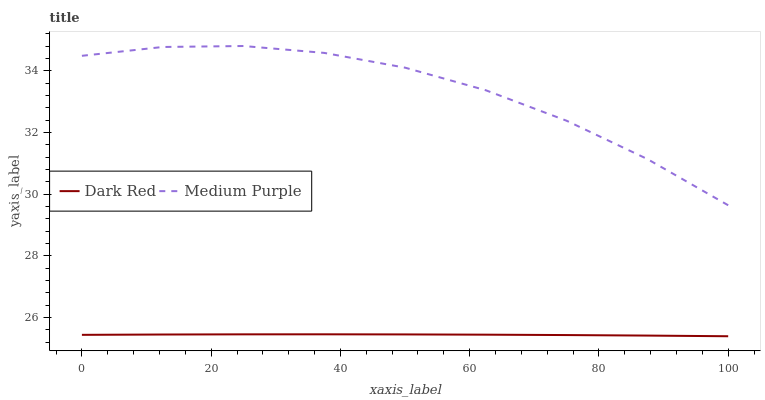Does Dark Red have the minimum area under the curve?
Answer yes or no. Yes. Does Medium Purple have the maximum area under the curve?
Answer yes or no. Yes. Does Dark Red have the maximum area under the curve?
Answer yes or no. No. Is Dark Red the smoothest?
Answer yes or no. Yes. Is Medium Purple the roughest?
Answer yes or no. Yes. Is Dark Red the roughest?
Answer yes or no. No. Does Dark Red have the lowest value?
Answer yes or no. Yes. Does Medium Purple have the highest value?
Answer yes or no. Yes. Does Dark Red have the highest value?
Answer yes or no. No. Is Dark Red less than Medium Purple?
Answer yes or no. Yes. Is Medium Purple greater than Dark Red?
Answer yes or no. Yes. Does Dark Red intersect Medium Purple?
Answer yes or no. No. 